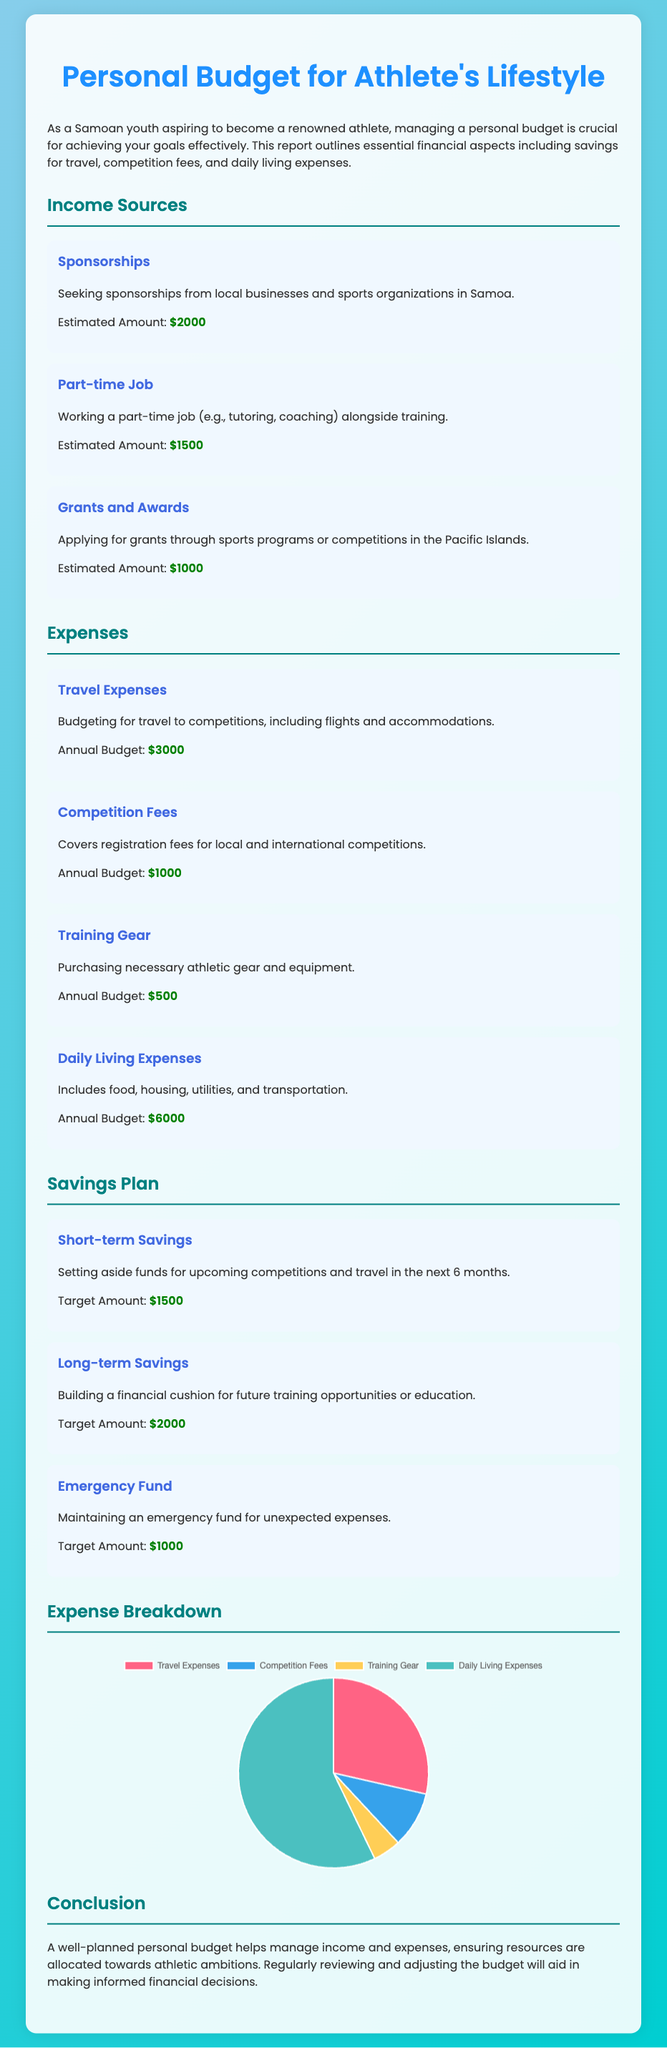What is the total estimated income? The total estimated income is the sum of all income sources: $2000 + $1500 + $1000 = $4500.
Answer: $4500 What is the annual budget for daily living expenses? The document states the annual budget for daily living expenses is $6000.
Answer: $6000 What is the target amount for short-term savings? The target amount for short-term savings mentioned in the document is $1500.
Answer: $1500 What are the travel expenses for the year? The annual budget allocated for travel expenses is $3000.
Answer: $3000 Which category has the highest annual budget? Based on the expense breakdown, daily living expenses has the highest annual budget at $6000.
Answer: Daily Living Expenses How much money is allocated for competition fees? The document indicates that the annual budget for competition fees is $1000.
Answer: $1000 What is the total amount set aside for the emergency fund? The target amount set aside for the emergency fund is $1000.
Answer: $1000 What funding sources are mentioned in the income section? The income section mentions sponsorships, part-time job, and grants and awards as funding sources.
Answer: Sponsorships, Part-time Job, Grants and Awards How much funding is expected from grants and awards? The estimated amount from grants and awards is specified as $1000.
Answer: $1000 